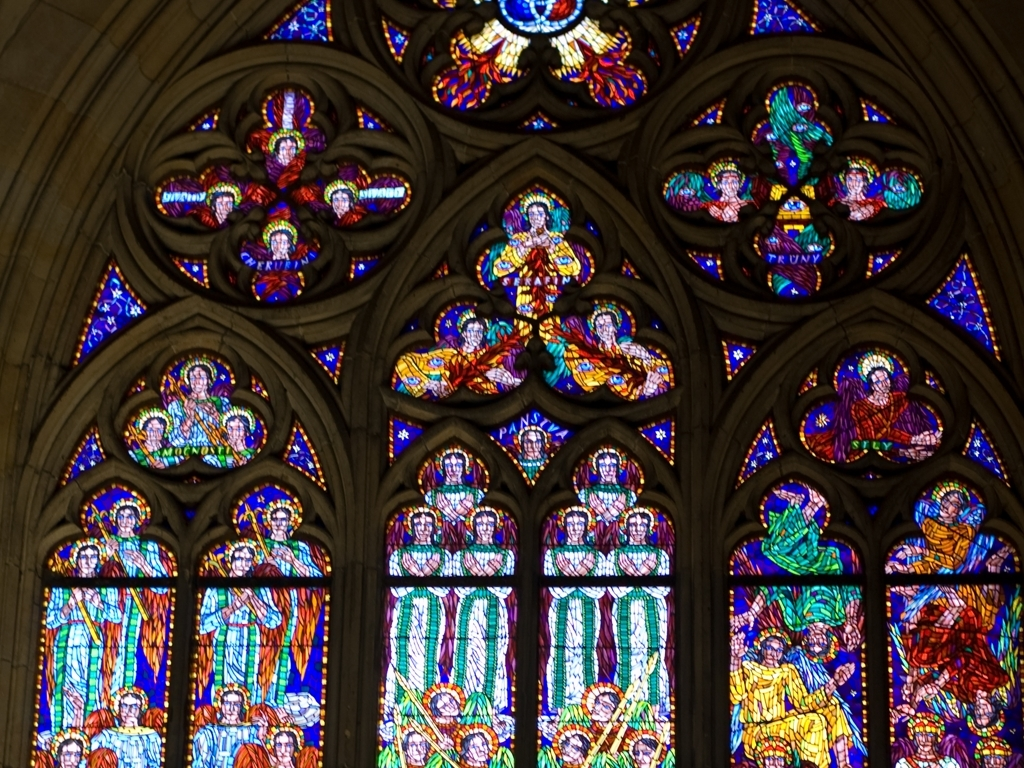What is the overall clarity of the image?
A. Poor
B. Crystal clear
C. Moderate
D. Excellent The overall clarity of the image can be rated as moderate; the details and colors are visible, but there is a softness to the edges and some areas lack sharpness, which is characteristic of the medium of stained glass. However, the craftsmanship and vibrant colors still come through effectively. 